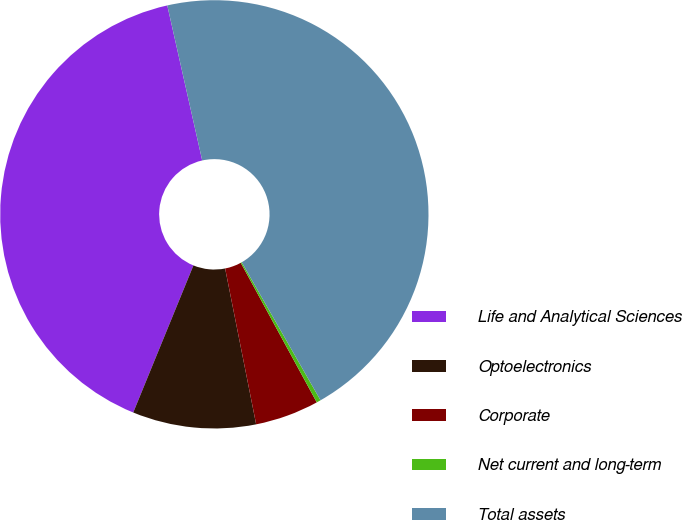Convert chart to OTSL. <chart><loc_0><loc_0><loc_500><loc_500><pie_chart><fcel>Life and Analytical Sciences<fcel>Optoelectronics<fcel>Corporate<fcel>Net current and long-term<fcel>Total assets<nl><fcel>40.29%<fcel>9.31%<fcel>4.81%<fcel>0.32%<fcel>45.27%<nl></chart> 